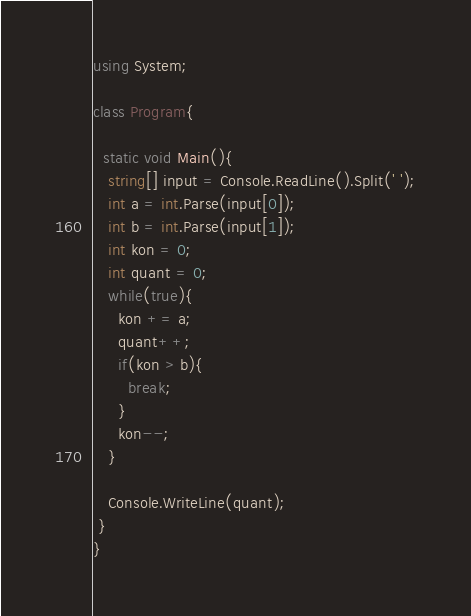Convert code to text. <code><loc_0><loc_0><loc_500><loc_500><_C#_>using System;

class Program{
  
  static void Main(){
   string[] input = Console.ReadLine().Split(' ');
   int a = int.Parse(input[0]);
   int b = int.Parse(input[1]); 
   int kon = 0;
   int quant = 0;
   while(true){
     kon += a;
     quant++;
     if(kon > b){
       break; 
     }
     kon--;
   }

   Console.WriteLine(quant);
 }
}</code> 